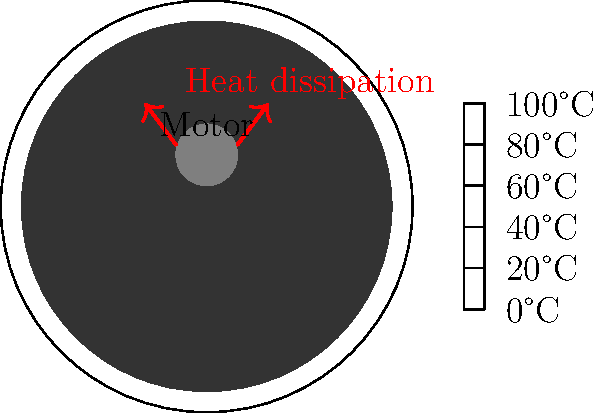You're spinning some classic Tupac vinyl on your turntable when you notice the motor's getting hotter than usual. The motor's steady-state temperature is 80°C, and the ambient temperature is 20°C. If the motor's thermal resistance to the environment is 3°C/W, calculate the heat transfer rate from the motor. How might this heat affect the vinyl's sound quality? Let's break this down step-by-step, keeping it real like Tupac's lyrics:

1) First, we need to identify the key information:
   - Motor temperature (T_motor) = 80°C
   - Ambient temperature (T_ambient) = 20°C
   - Thermal resistance (R) = 3°C/W

2) The heat transfer rate (Q) is given by the equation:

   $$ Q = \frac{\Delta T}{R} $$

   Where $\Delta T$ is the temperature difference between the motor and the environment.

3) Calculate $\Delta T$:
   $$ \Delta T = T_{motor} - T_{ambient} = 80°C - 20°C = 60°C $$

4) Now, plug the values into the heat transfer equation:

   $$ Q = \frac{60°C}{3°C/W} = 20W $$

5) Regarding the effect on sound quality:
   - The excess heat could cause the vinyl to warp slightly, leading to pitch variations.
   - It might also cause the lubricant in the motor bearings to thin, potentially increasing motor vibrations.
   - These factors could result in subtle distortions, much like how modern auto-tune can mess with the raw authenticity of classic hip-hop vocals.
Answer: 20W; may cause vinyl warping and increased motor vibrations, potentially distorting sound. 